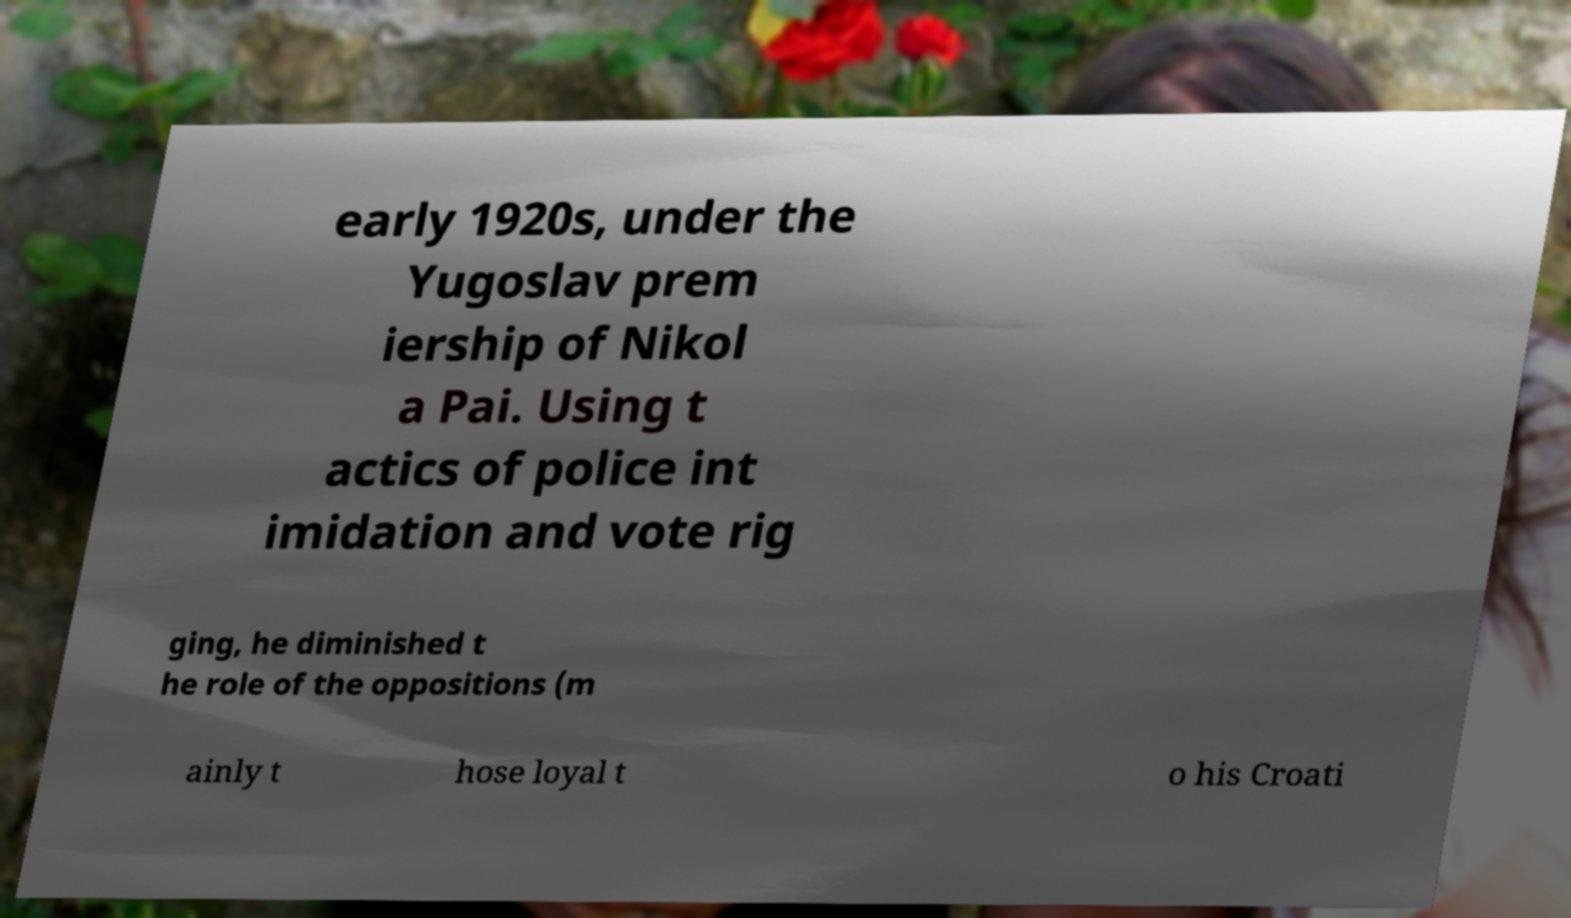For documentation purposes, I need the text within this image transcribed. Could you provide that? early 1920s, under the Yugoslav prem iership of Nikol a Pai. Using t actics of police int imidation and vote rig ging, he diminished t he role of the oppositions (m ainly t hose loyal t o his Croati 